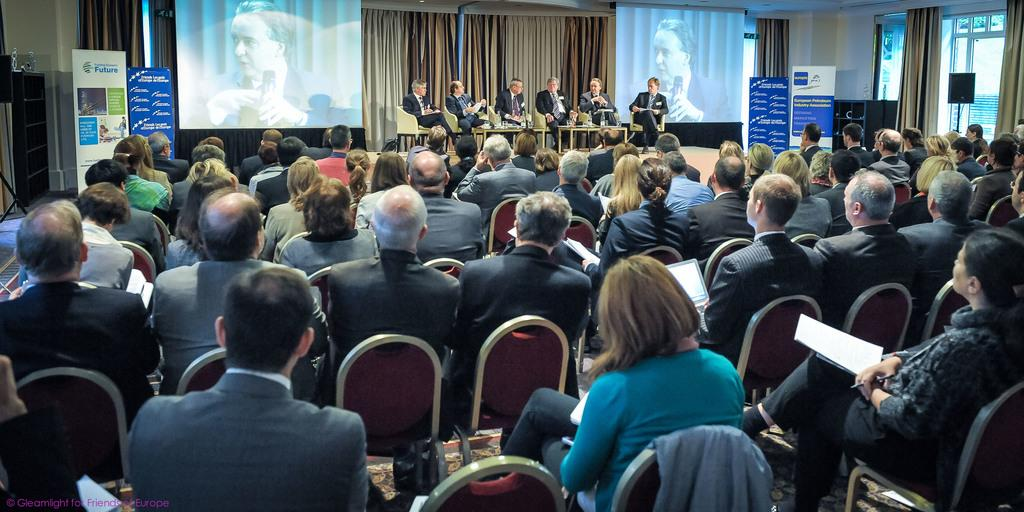What are the people in the image doing? There are people sitting on chairs in the image. What can be seen in the background of the image? There are curtains in the background of the image. What type of visual aids are being used in the image? There are two powerpoint presentations visible in the image. What type of lunch is being served during the meeting in the image? There is no lunch visible in the image; it only shows people sitting on chairs and two powerpoint presentations. 